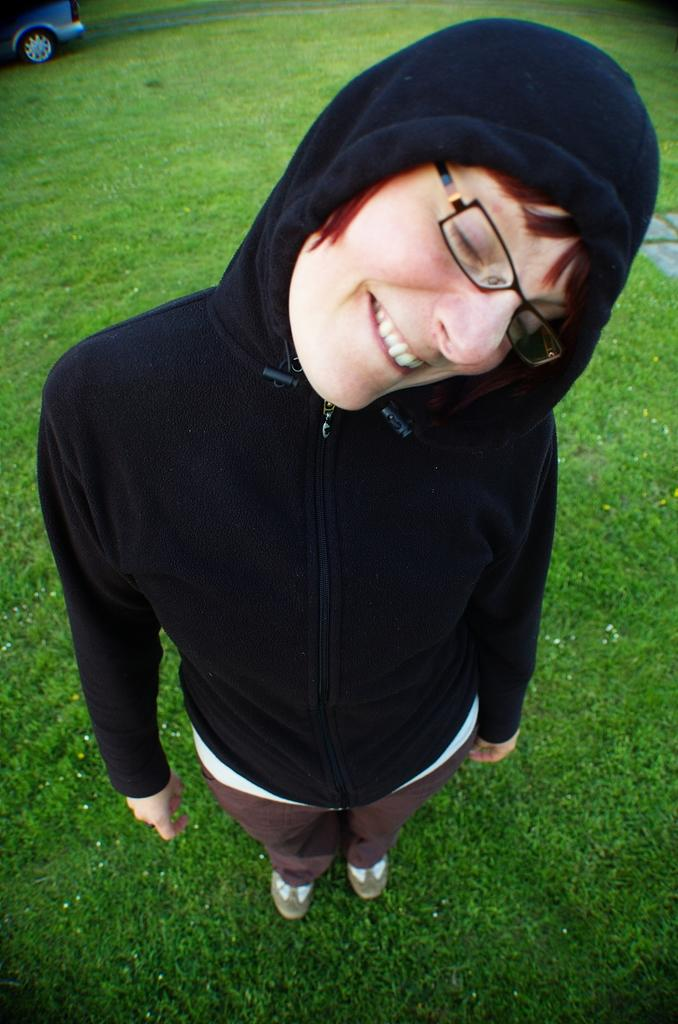What is the person in the image doing? The person is standing in the image and smiling. What is the ground made of in the image? There is grass on the ground in the image. What can be seen in the background of the image? There is a vehicle visible in the background of the image. What direction is the owl flying in the image? There is no owl present in the image, so it is not possible to determine the direction in which it might be flying. 